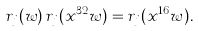Convert formula to latex. <formula><loc_0><loc_0><loc_500><loc_500>r _ { j } ( w ) \, r _ { j } ( x ^ { 3 2 } w ) = r _ { j } ( x ^ { 1 6 } w ) .</formula> 